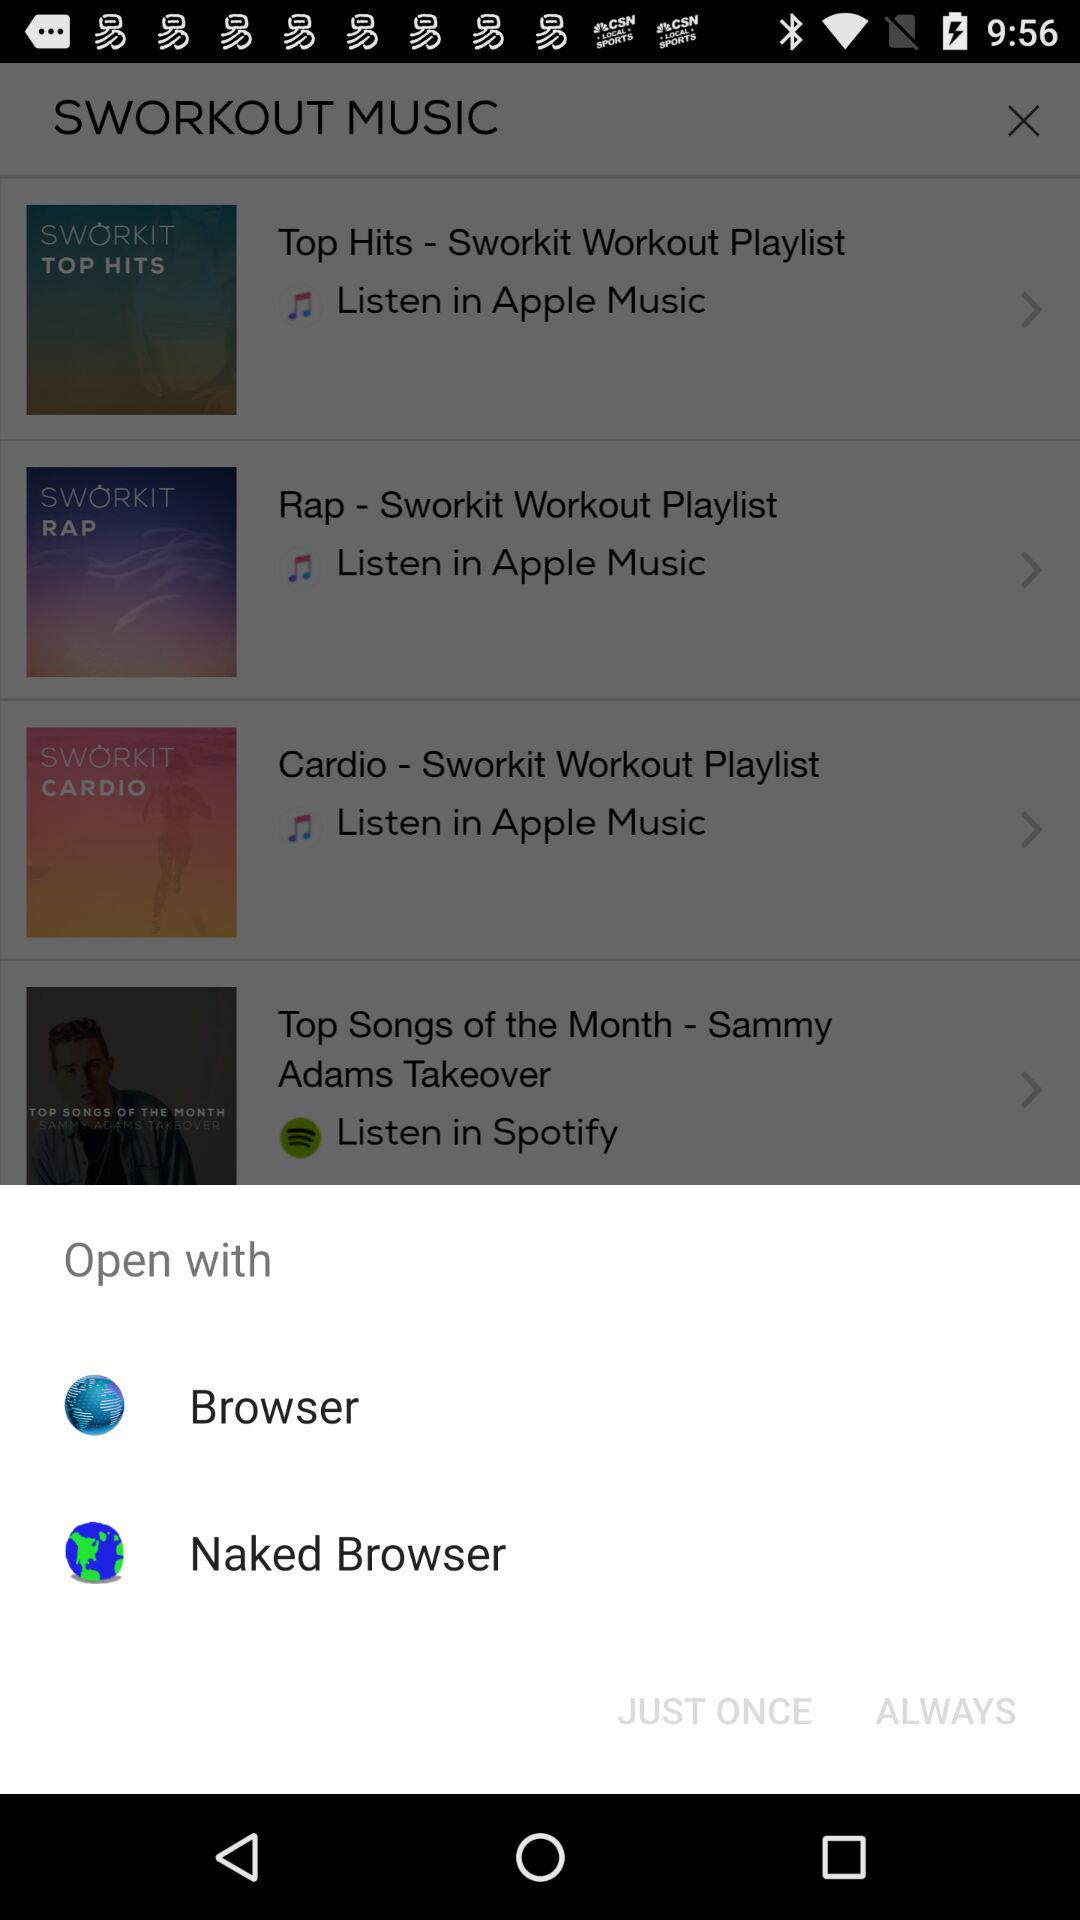How many apps can I open the music with?
Answer the question using a single word or phrase. 2 